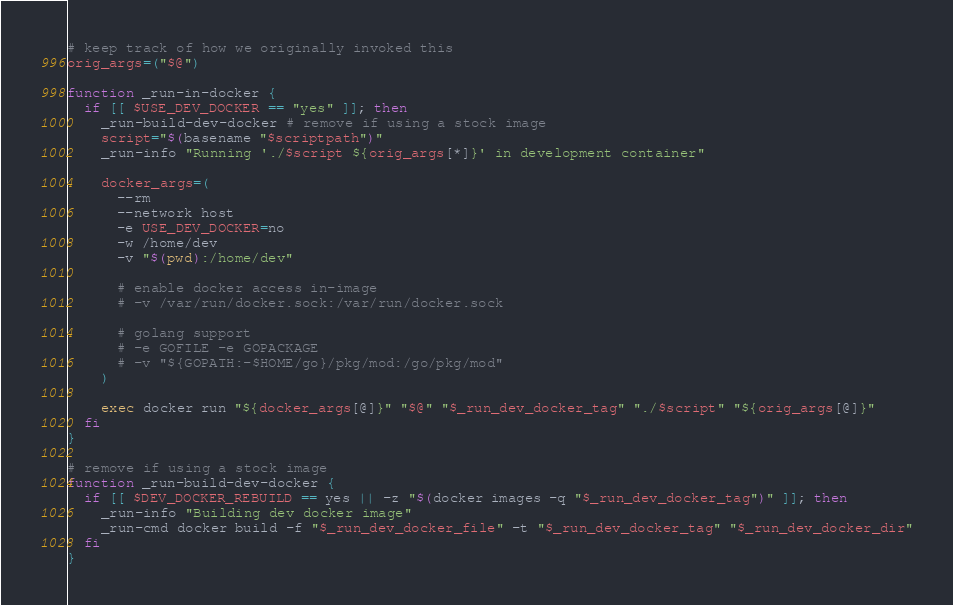Convert code to text. <code><loc_0><loc_0><loc_500><loc_500><_Bash_>
# keep track of how we originally invoked this
orig_args=("$@")

function _run-in-docker {
  if [[ $USE_DEV_DOCKER == "yes" ]]; then
    _run-build-dev-docker # remove if using a stock image
    script="$(basename "$scriptpath")"
    _run-info "Running './$script ${orig_args[*]}' in development container"

    docker_args=(
      --rm
      --network host
      -e USE_DEV_DOCKER=no
      -w /home/dev
      -v "$(pwd):/home/dev"

      # enable docker access in-image
      # -v /var/run/docker.sock:/var/run/docker.sock

      # golang support
      # -e GOFILE -e GOPACKAGE
      # -v "${GOPATH:-$HOME/go}/pkg/mod:/go/pkg/mod"
    )
    
    exec docker run "${docker_args[@]}" "$@" "$_run_dev_docker_tag" "./$script" "${orig_args[@]}"
  fi
}

# remove if using a stock image
function _run-build-dev-docker {
  if [[ $DEV_DOCKER_REBUILD == yes || -z "$(docker images -q "$_run_dev_docker_tag")" ]]; then
    _run-info "Building dev docker image"
    _run-cmd docker build -f "$_run_dev_docker_file" -t "$_run_dev_docker_tag" "$_run_dev_docker_dir"
  fi
}
</code> 